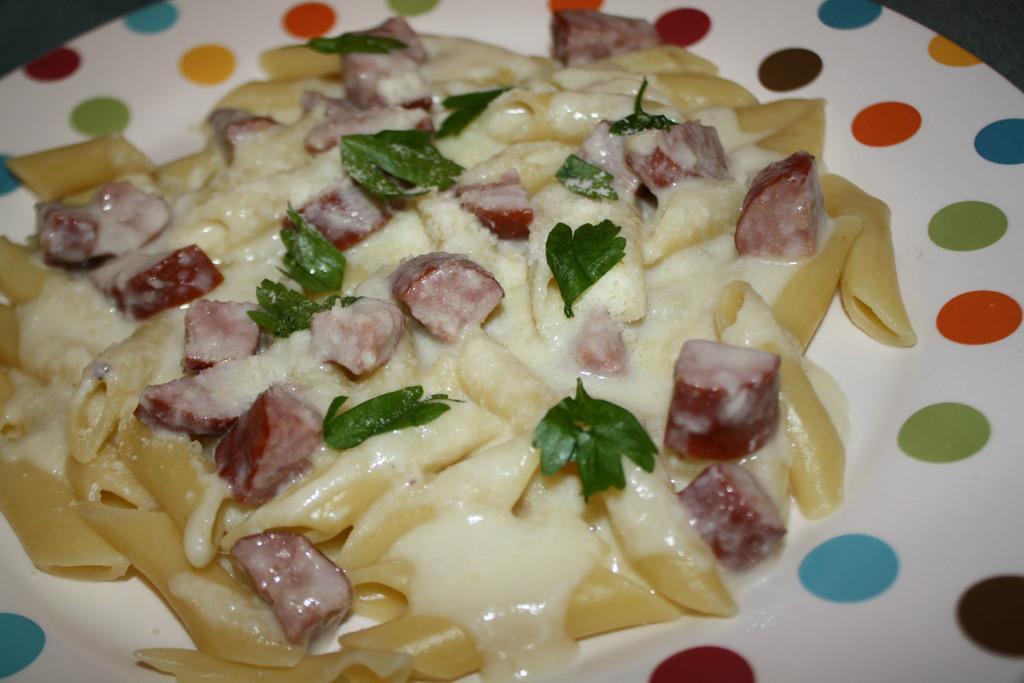Describe this image in one or two sentences. In this image I can see a food on the colorful plate. Food is in white, cream, red and green color. 